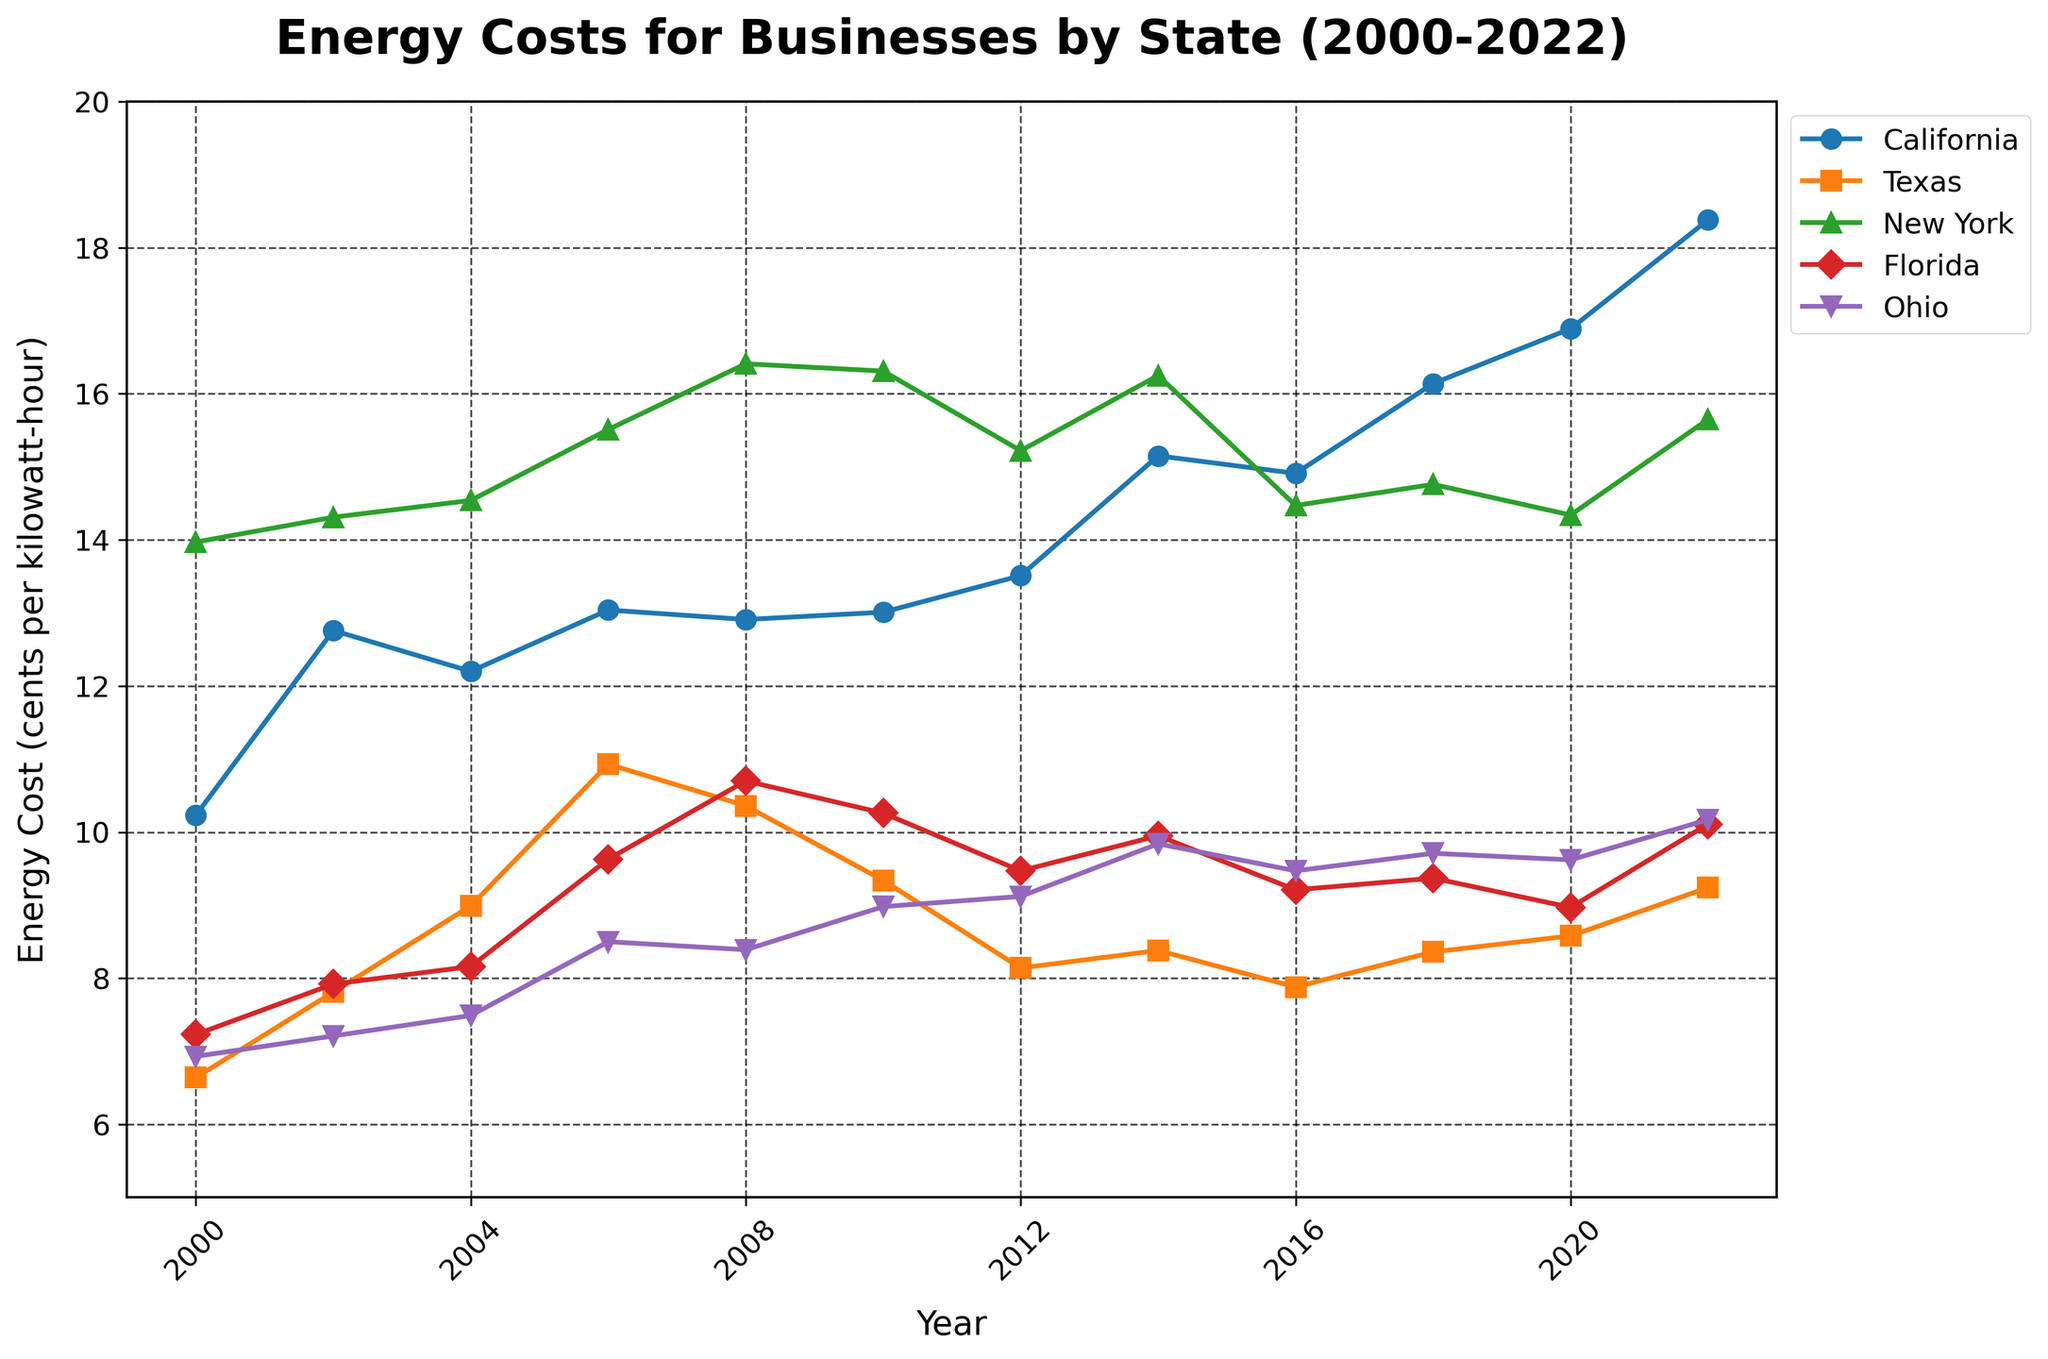What is the overall trend in energy costs for California from 2000 to 2022? The graph shows that energy costs for California businesses have generally increased over time, rising from 10.23 cents per kilowatt-hour in 2000 to 18.38 cents per kilowatt-hour in 2022.
Answer: Increasing Which state had the lowest energy costs in the year 2010? In the figure, Texas had the lowest energy costs in 2010, with a value of 9.34 cents per kilowatt-hour.
Answer: Texas By what amount did energy costs increase in Florida from 2000 to 2022? Energy costs in Florida increased from 7.23 cents per kilowatt-hour in 2000 to 10.11 cents per kilowatt-hour in 2022. The difference is 10.11 - 7.23 = 2.88 cents.
Answer: 2.88 cents Which state has the most volatile energy costs over the given period? California's energy costs display the greatest fluctuation over the years, with significant increases and decreases compared to other states, suggesting higher volatility.
Answer: California How did energy costs in Ohio change from 2004 to 2010? In the figure, Ohio's energy costs increased from 7.49 cents in 2004 to 8.98 cents by 2010. The change is 8.98 - 7.49 = 1.49 cents increase.
Answer: 1.49 cents increase Is there a year where New York's energy costs declined compared to the previous year? Yes, New York's energy costs decreased from 16.41 cents per kilowatt-hour in 2008 to 16.31 cents per kilowatt-hour in 2010.
Answer: Yes Which state had the highest average energy costs between 2000 and 2022? To determine the average, add the costs for all years and divide by the number of years (12 years). Performing this calculation across the states shows that California consistently has higher costs compared to the others.
Answer: California Did Texas experience a continuous increase in energy costs over the years? No, Texas experienced fluctuations. Their energy costs increased until 2006, decreased from 2008, had a drop in 2010 every two years, showing a general trend of varying ups and downs.
Answer: No Which state showed the smallest increase in energy costs from 2000 to 2022? Texas saw the smallest increase from 6.64 cents in 2000 to 9.24 cents in 2022. The increase is 9.24 - 6.64 = 2.60 cents. Comparing the differences for all states confirms Texas's position.
Answer: Texas 